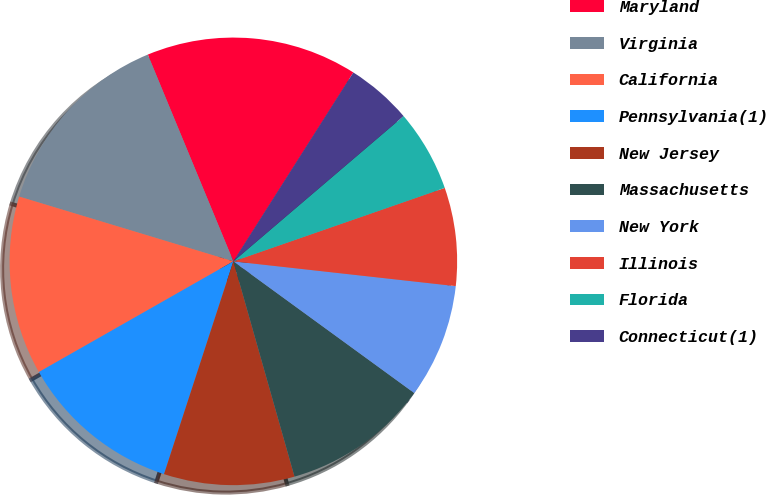<chart> <loc_0><loc_0><loc_500><loc_500><pie_chart><fcel>Maryland<fcel>Virginia<fcel>California<fcel>Pennsylvania(1)<fcel>New Jersey<fcel>Massachusetts<fcel>New York<fcel>Illinois<fcel>Florida<fcel>Connecticut(1)<nl><fcel>15.25%<fcel>14.08%<fcel>12.91%<fcel>11.75%<fcel>9.42%<fcel>10.58%<fcel>8.25%<fcel>7.09%<fcel>5.92%<fcel>4.75%<nl></chart> 